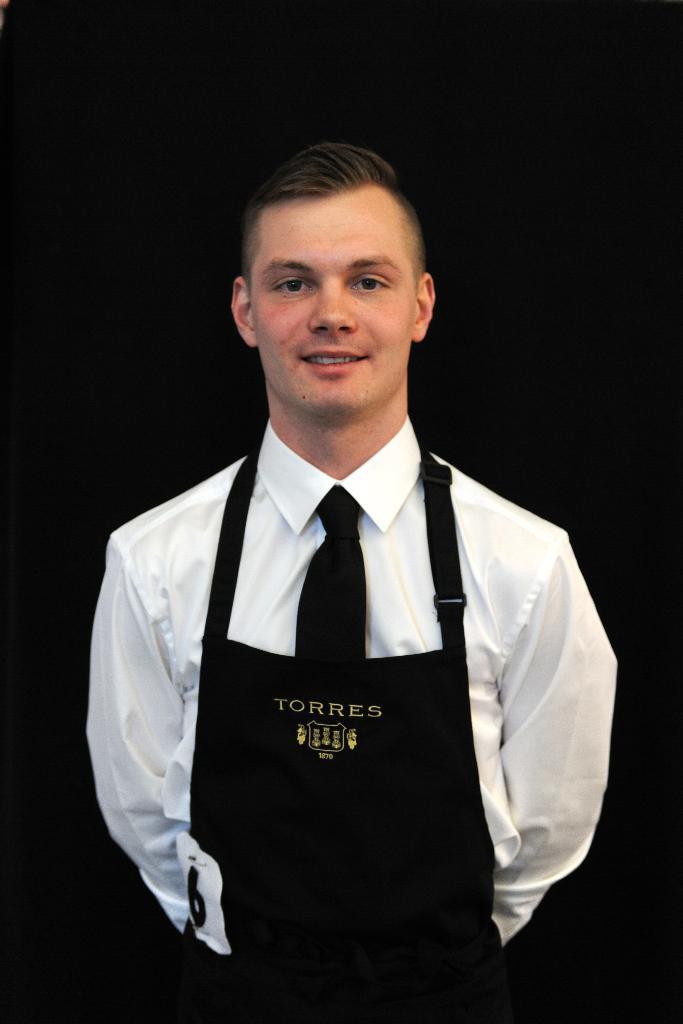Can you describe this image briefly? In the middle of the image a person is standing, smiling and he wear a cloth. 